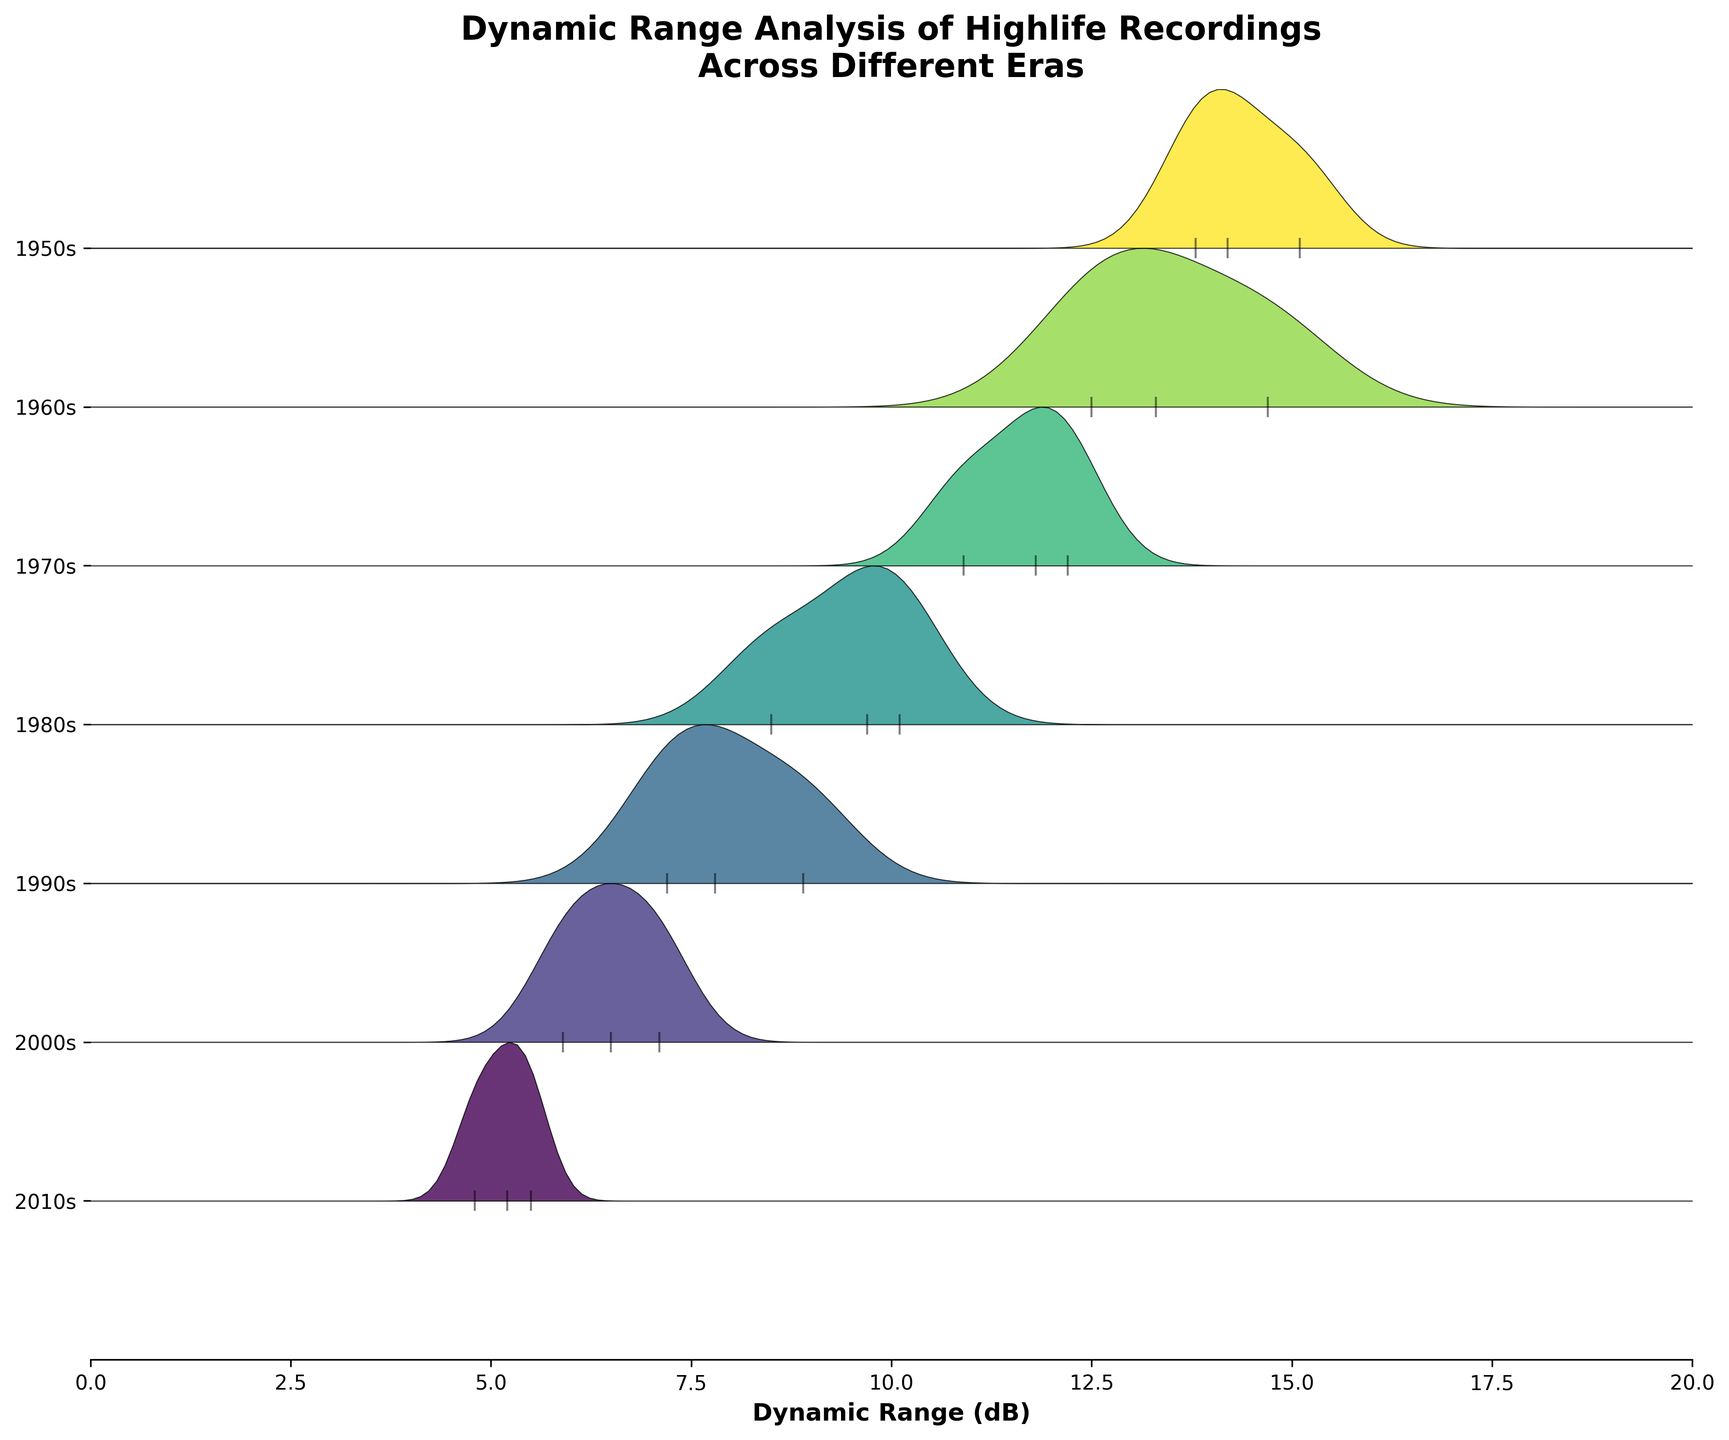What is the title of the figure? The title is usually located at the top of the figure. Here, it states: "Dynamic Range Analysis of Highlife Recordings Across Different Eras."
Answer: Dynamic Range Analysis of Highlife Recordings Across Different Eras What is the range of the x-axis? The x-axis indicates the range by the values at its ends. Here, it ranges from 0 to 20.
Answer: 0 to 20 Which era shows the highest dynamic range in any of its recordings? By observing the highest peaks in the ridgeline plot, the 1950s show a dynamic range that extends the furthest to the right around 15.1 dB.
Answer: 1950s How does the dynamic range distribution of the 2000s compare to the 1950s? The 2000s show recordings with a lower dynamic range (concentrated around 5.9 to 7.1 dB), while the 1950s have higher dynamic ranges (around 13.8 to 15.1 dB). This indicates a decline over time.
Answer: The 2000s have lower dynamic ranges than the 1950s What is the average dynamic range of the 1970s recordings? The dynamic ranges of the 1970s recordings are 11.8, 10.9, and 12.2 dB. Calculating the average: (11.8 + 10.9 + 12.2) / 3 = 11.63 dB.
Answer: 11.63 dB Which era has the lowest median dynamic range? By inspecting the central tendency of the distributions, the 2010s show the lowest median dynamic range, centered around 5.2 to 5.5 dB.
Answer: 2010s How many eras are depicted in the ridgeline plot? The y-axis labels each era, and counting them from top to bottom gives a total of six eras.
Answer: Six Do any of the recordings in the 1980s have a dynamic range higher than 10 dB? Observing the markers for the 1980s, only one recording has a dynamic range around 10.1 dB, which is higher than 10 dB.
Answer: Yes Which era has the most spread-out dynamic range values? The 1950s show the most spread because they have the widest distribution of dynamic range values, ranging from around 13.8 to 15.1 dB.
Answer: 1950s What is the visible trend in dynamic range from the 1950s to the 2010s? The dynamic range seems to decrease gradually from the 1950s (highest around 15.1 dB) to the 2010s (lowest around 4.8 dB), indicating a temporal decline in dynamic range in highlife recordings.
Answer: A decrease in dynamic range 